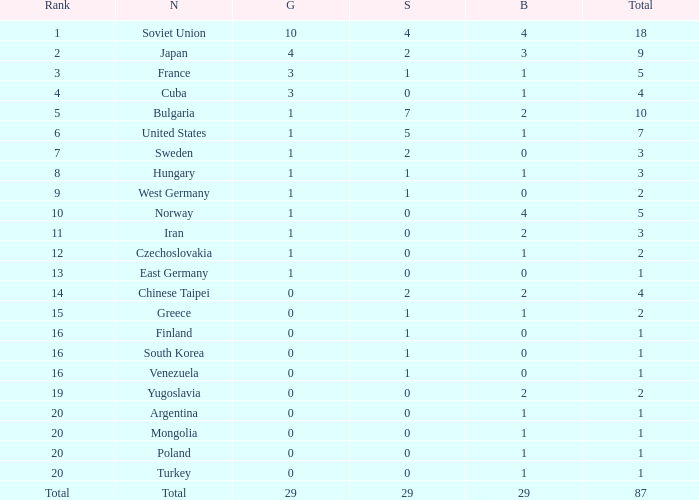What is the sum of gold medals for a rank of 14? 0.0. 